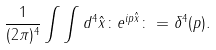<formula> <loc_0><loc_0><loc_500><loc_500>\frac { 1 } { ( 2 \pi ) ^ { 4 } } \int \int d ^ { 4 } \hat { x } \colon e ^ { i p \hat { x } } \colon = \delta ^ { 4 } ( p ) .</formula> 